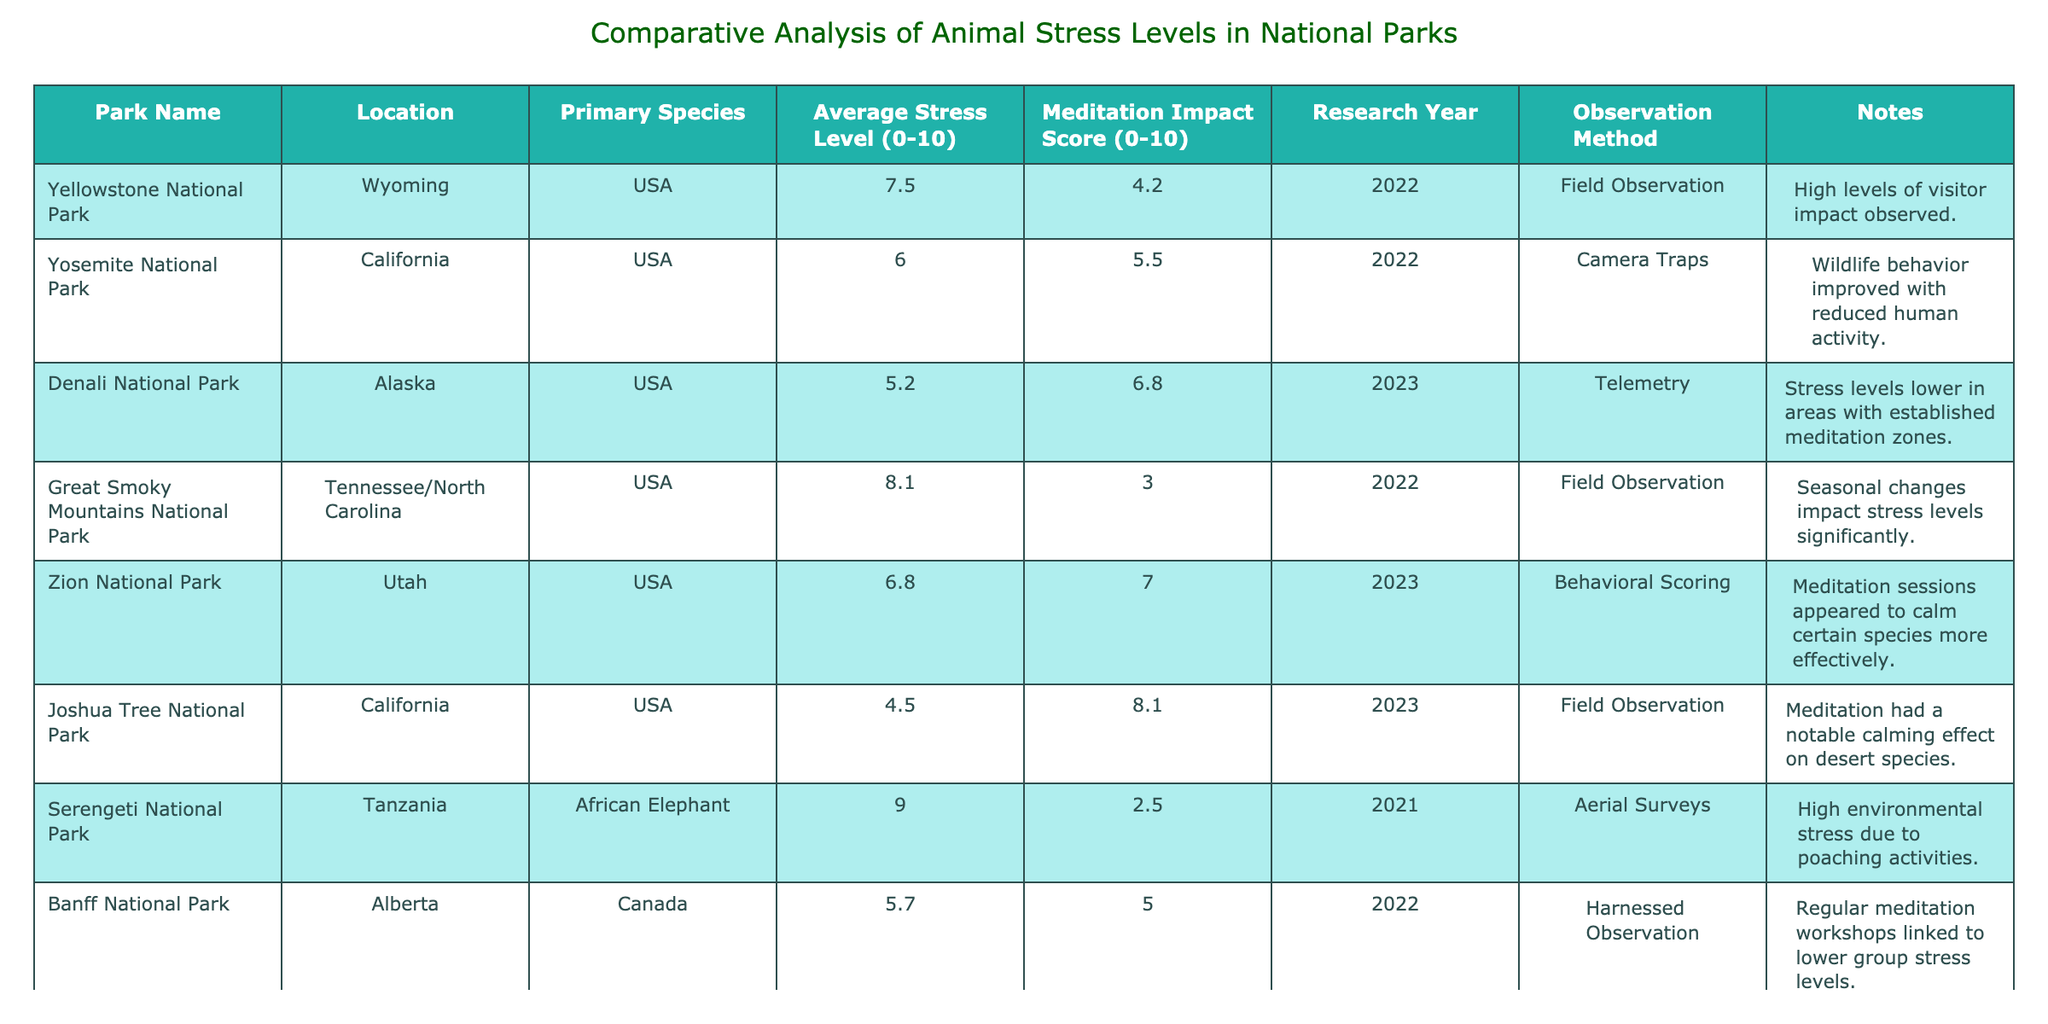What is the average stress level of animals in Yellowstone National Park? The average stress level of animals in Yellowstone National Park is 7.5, as directly listed in the table under the "Average Stress Level (0-10)" column for that park.
Answer: 7.5 Which national park has the highest average stress level? Serengeti National Park has the highest average stress level of 9.0, as seen in the table where it clearly has the highest value in the "Average Stress Level (0-10)" column.
Answer: Serengeti National Park Is meditation shown to have any impact on stress levels in Joshua Tree National Park? Yes, the table indicates a Meditation Impact Score of 8.1 for Joshua Tree National Park, suggesting that meditation had a notable calming effect on the desert species, which supports the idea that meditation positively impacted stress levels.
Answer: Yes How many parks have an average stress level below 6.0? There are three parks (Denali National Park, Joshua Tree National Park, and Yellowstone National Park) that have stress levels below 6.0: 5.2, 4.5, and 7.5 respectively. The relevant parks are identified by checking the "Average Stress Level (0-10)" column for values under 6.0.
Answer: 2 What is the difference in average stress levels between the highest and the lowest park? The highest average stress level is 9.0 from Serengeti National Park and the lowest average is 4.5 from Joshua Tree National Park. So, the difference is 9.0 - 4.5 = 4.5. The final step is simply subtracting the lowest average from the highest.
Answer: 4.5 In terms of meditation impact, which park appears to benefit most? Joshua Tree National Park is shown to have the highest Meditation Impact Score of 8.1, indicating it benefited the most from meditation initiatives, as observed in the "Meditation Impact Score (0-10)" column.
Answer: Joshua Tree National Park Are the animals in Great Smoky Mountains National Park more stressed than those in Denali National Park? Yes, animals in Great Smoky Mountains National Park have an average stress level of 8.1 compared to 5.2 in Denali National Park. To reach this conclusion, I compared the two values directly from the "Average Stress Level (0-10)" column.
Answer: Yes What observation method was used in the study involving Zion National Park? The observation method for Zion National Park was "Behavioral Scoring," as stated in the "Observation Method" column of the table.
Answer: Behavioral Scoring 